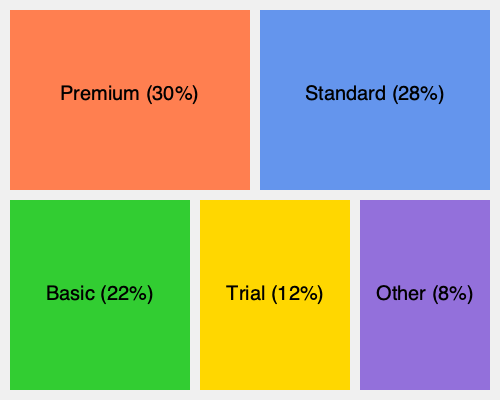Based on the treemap visualization of customer segments, which segment has the largest market share, and what is the combined percentage of the top two segments? To answer this question, we need to follow these steps:

1. Identify the largest segment:
   - Premium: 30%
   - Standard: 28%
   - Basic: 22%
   - Trial: 12%
   - Other: 8%

   The largest segment is Premium with 30% market share.

2. Identify the second-largest segment:
   The second-largest segment is Standard with 28% market share.

3. Calculate the combined percentage of the top two segments:
   $30\% + 28\% = 58\%$

Therefore, the Premium segment has the largest market share, and the combined percentage of the top two segments (Premium and Standard) is 58%.
Answer: Premium; 58% 